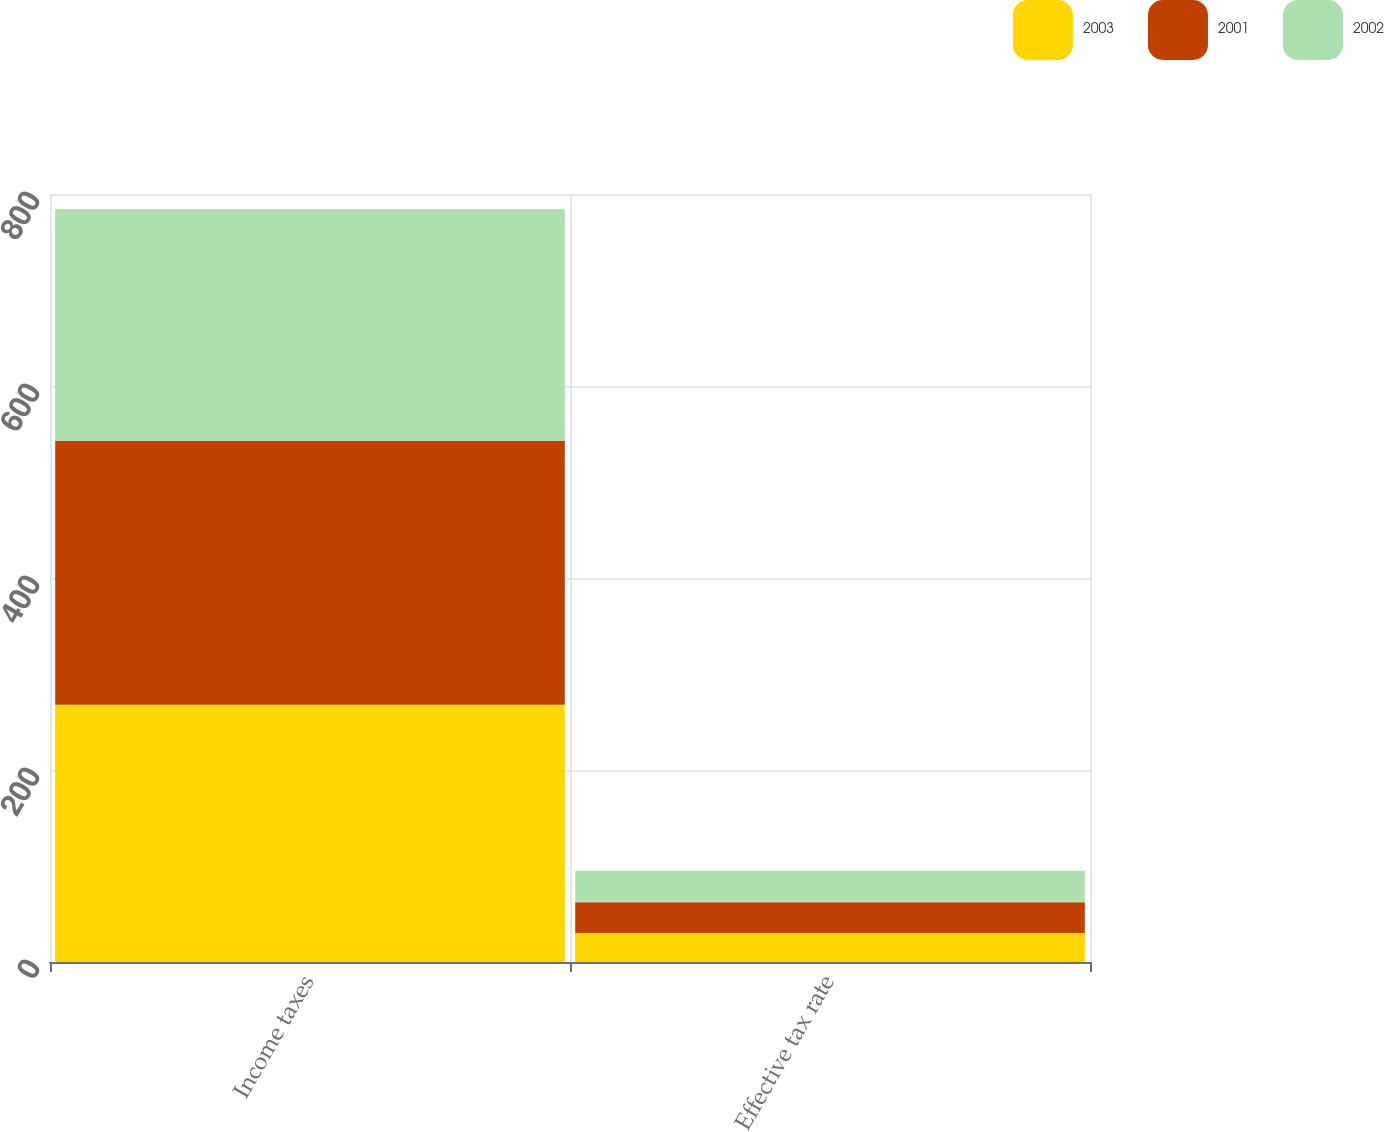<chart> <loc_0><loc_0><loc_500><loc_500><stacked_bar_chart><ecel><fcel>Income taxes<fcel>Effective tax rate<nl><fcel>2003<fcel>268<fcel>30.2<nl><fcel>2001<fcel>275<fcel>32.1<nl><fcel>2002<fcel>241<fcel>32.8<nl></chart> 